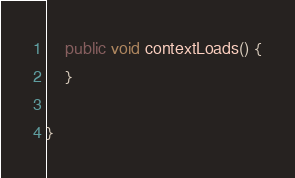Convert code to text. <code><loc_0><loc_0><loc_500><loc_500><_Java_>    public void contextLoads() {
    }

}
</code> 